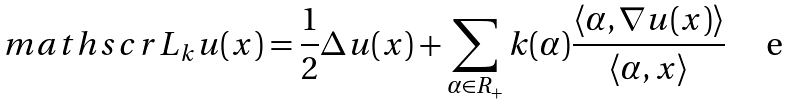Convert formula to latex. <formula><loc_0><loc_0><loc_500><loc_500>\ m a t h s c r { L } _ { k } u ( x ) = \frac { 1 } { 2 } \Delta u ( x ) + \sum _ { \alpha \in R _ { + } } k ( \alpha ) \frac { \langle \alpha , \nabla u ( x ) \rangle } { \langle \alpha , x \rangle }</formula> 